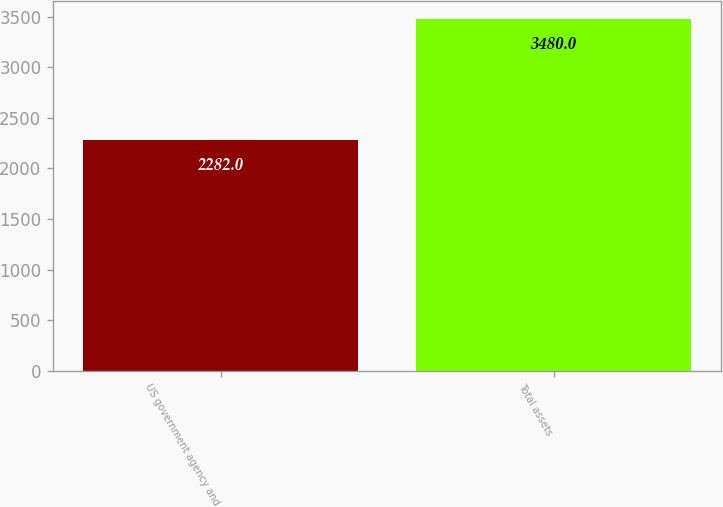<chart> <loc_0><loc_0><loc_500><loc_500><bar_chart><fcel>US government agency and<fcel>Total assets<nl><fcel>2282<fcel>3480<nl></chart> 